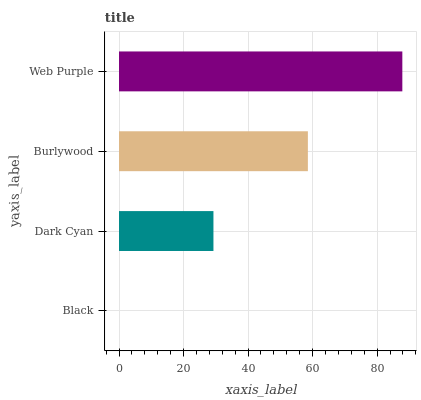Is Black the minimum?
Answer yes or no. Yes. Is Web Purple the maximum?
Answer yes or no. Yes. Is Dark Cyan the minimum?
Answer yes or no. No. Is Dark Cyan the maximum?
Answer yes or no. No. Is Dark Cyan greater than Black?
Answer yes or no. Yes. Is Black less than Dark Cyan?
Answer yes or no. Yes. Is Black greater than Dark Cyan?
Answer yes or no. No. Is Dark Cyan less than Black?
Answer yes or no. No. Is Burlywood the high median?
Answer yes or no. Yes. Is Dark Cyan the low median?
Answer yes or no. Yes. Is Black the high median?
Answer yes or no. No. Is Burlywood the low median?
Answer yes or no. No. 